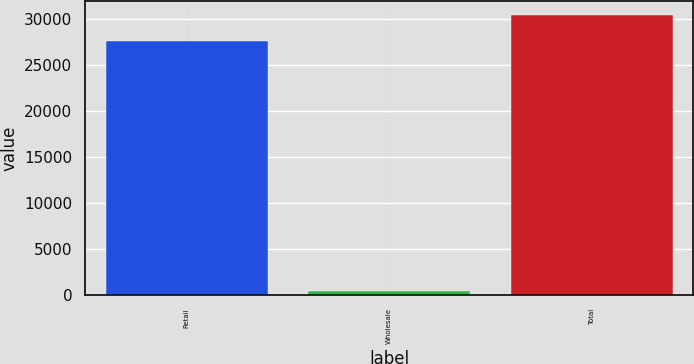Convert chart. <chart><loc_0><loc_0><loc_500><loc_500><bar_chart><fcel>Retail<fcel>Wholesale<fcel>Total<nl><fcel>27597<fcel>436<fcel>30356.7<nl></chart> 